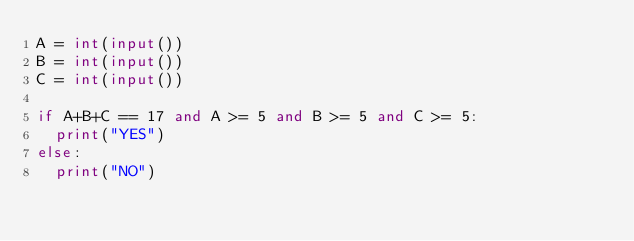<code> <loc_0><loc_0><loc_500><loc_500><_Python_>A = int(input())
B = int(input())
C = int(input())

if A+B+C == 17 and A >= 5 and B >= 5 and C >= 5:
  print("YES")
else:
  print("NO")</code> 